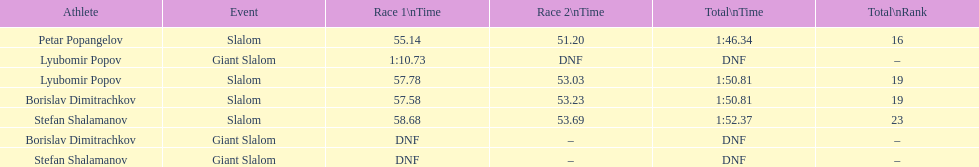Which athlete finished the first race but did not finish the second race? Lyubomir Popov. 